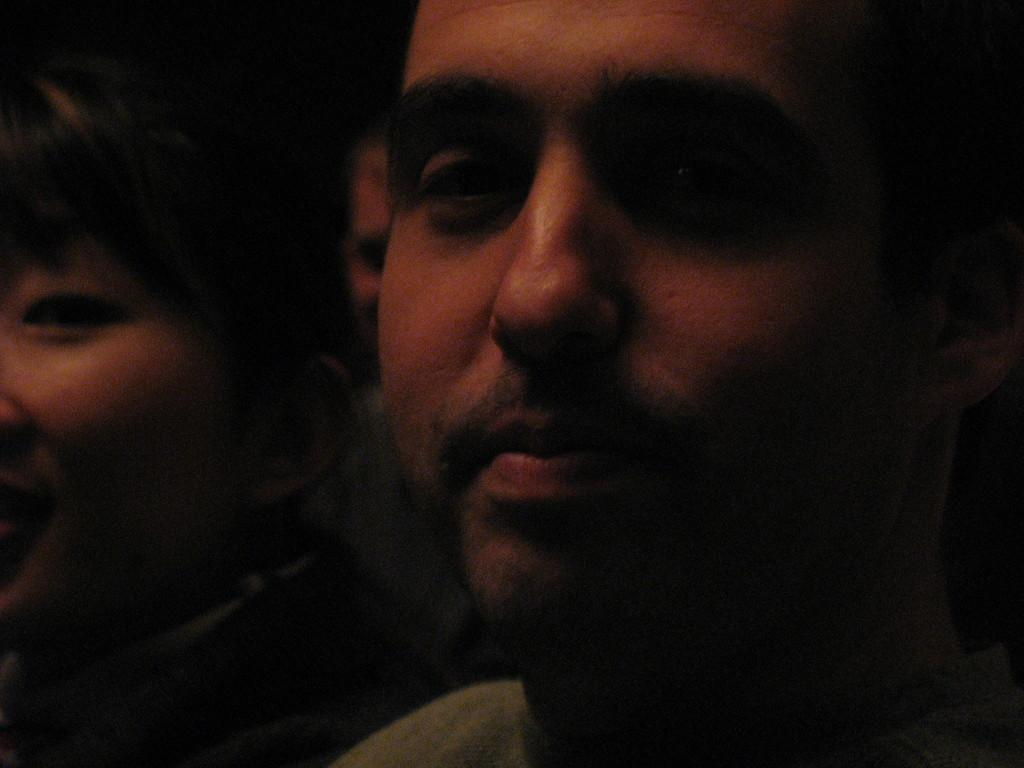How many people are in the image? There are three persons in the image. What can be observed about the background of the image? The background of the image is dark. What type of beam is being used by the persons in the image? There is no beam present in the image; it only features three persons and a dark background. What kind of jewel can be seen on the person's clothing in the image? There is no jewel visible on any of the person's clothing in the image. 